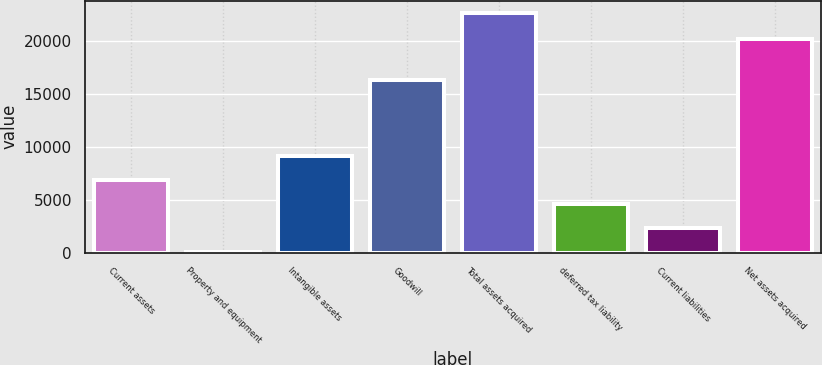Convert chart to OTSL. <chart><loc_0><loc_0><loc_500><loc_500><bar_chart><fcel>Current assets<fcel>Property and equipment<fcel>Intangible assets<fcel>Goodwill<fcel>Total assets acquired<fcel>deferred tax liability<fcel>Current liabilities<fcel>Net assets acquired<nl><fcel>6884.7<fcel>114<fcel>9141.6<fcel>16331<fcel>22683<fcel>4627.8<fcel>2370.9<fcel>20224<nl></chart> 